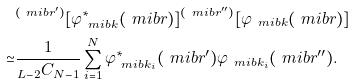<formula> <loc_0><loc_0><loc_500><loc_500>& ^ { ( \ m i b { r } ^ { \prime } ) } [ \varphi ^ { * } _ { \ m i b { k } } ( \ m i b { r } ) ] ^ { ( \ m i b { r } ^ { \prime \prime } ) } [ \varphi _ { \ m i b { k } } ( \ m i b { r } ) ] \\ \simeq & \frac { 1 } { _ { L - 2 } C _ { N - 1 } } \sum ^ { N } _ { i = 1 } \varphi ^ { * } _ { \ m i b { k } _ { i } } ( \ m i b { r } ^ { \prime } ) \varphi _ { \ m i b { k } _ { i } } ( \ m i b { r } ^ { \prime \prime } ) .</formula> 